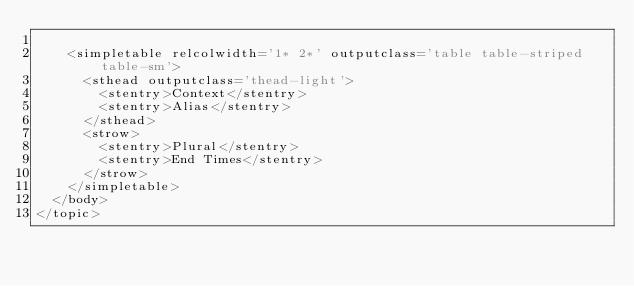<code> <loc_0><loc_0><loc_500><loc_500><_XML_>
    <simpletable relcolwidth='1* 2*' outputclass='table table-striped table-sm'>
      <sthead outputclass='thead-light'>
        <stentry>Context</stentry>
        <stentry>Alias</stentry>
      </sthead>
      <strow>
        <stentry>Plural</stentry>
        <stentry>End Times</stentry>
      </strow>
    </simpletable>
  </body>
</topic></code> 